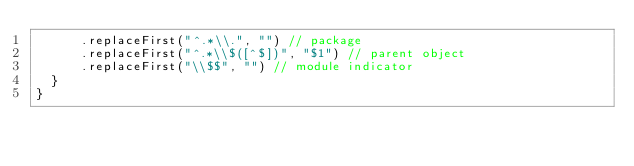<code> <loc_0><loc_0><loc_500><loc_500><_Scala_>      .replaceFirst("^.*\\.", "") // package
      .replaceFirst("^.*\\$([^$])", "$1") // parent object
      .replaceFirst("\\$$", "") // module indicator
  }
}
</code> 